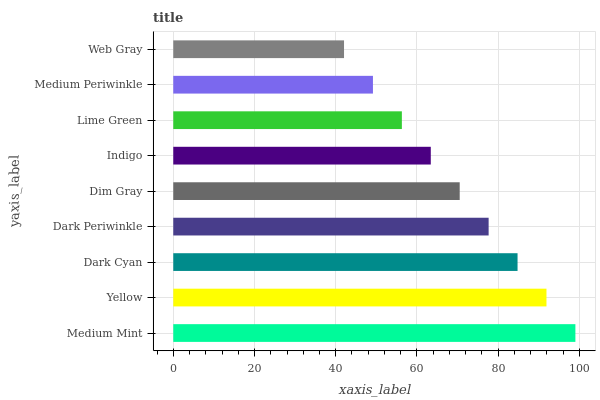Is Web Gray the minimum?
Answer yes or no. Yes. Is Medium Mint the maximum?
Answer yes or no. Yes. Is Yellow the minimum?
Answer yes or no. No. Is Yellow the maximum?
Answer yes or no. No. Is Medium Mint greater than Yellow?
Answer yes or no. Yes. Is Yellow less than Medium Mint?
Answer yes or no. Yes. Is Yellow greater than Medium Mint?
Answer yes or no. No. Is Medium Mint less than Yellow?
Answer yes or no. No. Is Dim Gray the high median?
Answer yes or no. Yes. Is Dim Gray the low median?
Answer yes or no. Yes. Is Medium Periwinkle the high median?
Answer yes or no. No. Is Lime Green the low median?
Answer yes or no. No. 